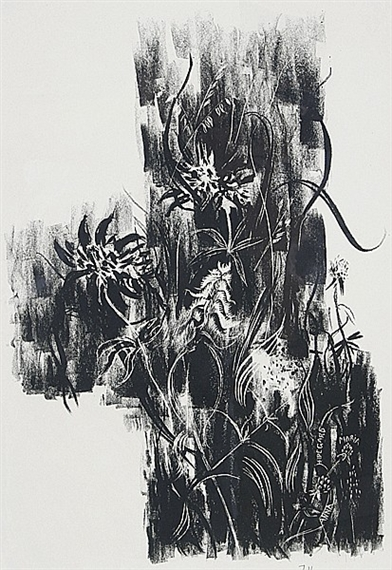I see some plant-like shapes in this artwork. Can you describe what kind of plants they might be? The plant-like shapes in this artwork seem reminiscent of wild, untamed flora, perhaps similar to ferns or thistles. Their forms are intricate and detailed, with long, graceful stems and wispy leaves. The texture and fluidity suggest they might be thriving in a natural, dense forest or an overgrown garden, where they sway gently with the breeze, adding to the dynamic movement within the piece. 